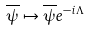Convert formula to latex. <formula><loc_0><loc_0><loc_500><loc_500>\overline { \psi } \mapsto \overline { \psi } e ^ { - i \Lambda }</formula> 